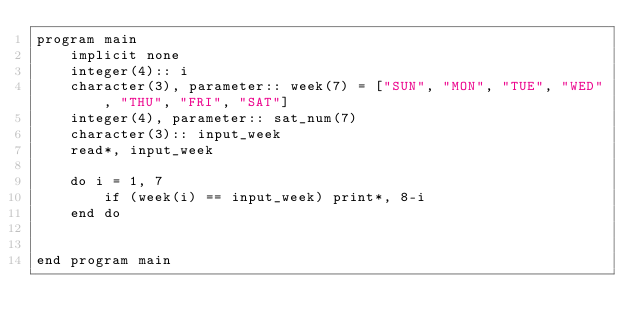Convert code to text. <code><loc_0><loc_0><loc_500><loc_500><_FORTRAN_>program main
    implicit none
    integer(4):: i
    character(3), parameter:: week(7) = ["SUN", "MON", "TUE", "WED", "THU", "FRI", "SAT"]
    integer(4), parameter:: sat_num(7) 
    character(3):: input_week
    read*, input_week

    do i = 1, 7
        if (week(i) == input_week) print*, 8-i
    end do


end program main</code> 